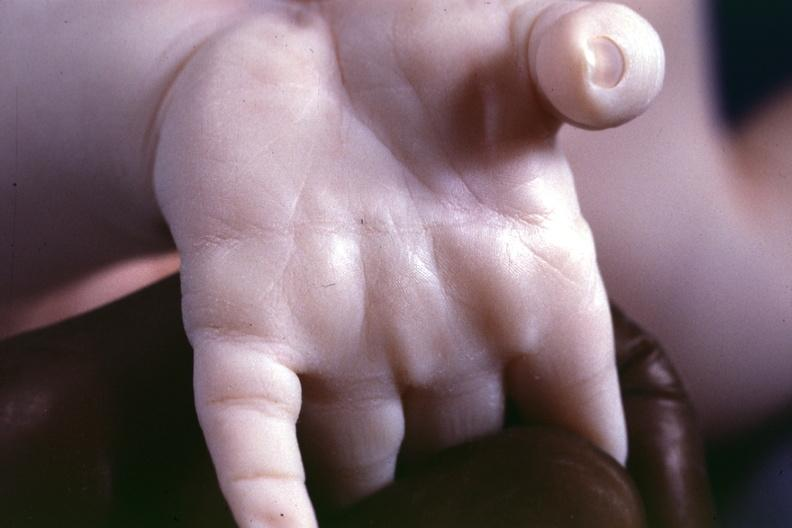s 70yof present?
Answer the question using a single word or phrase. No 